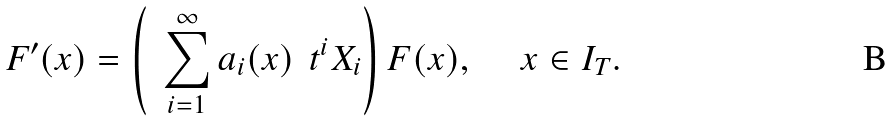Convert formula to latex. <formula><loc_0><loc_0><loc_500><loc_500>F ^ { \prime } ( x ) = \left ( \ \, \sum _ { i = 1 } ^ { \infty } a _ { i } ( x ) \ \, t ^ { i } X _ { i } \right ) F ( x ) , \quad \ x \in I _ { T } .</formula> 